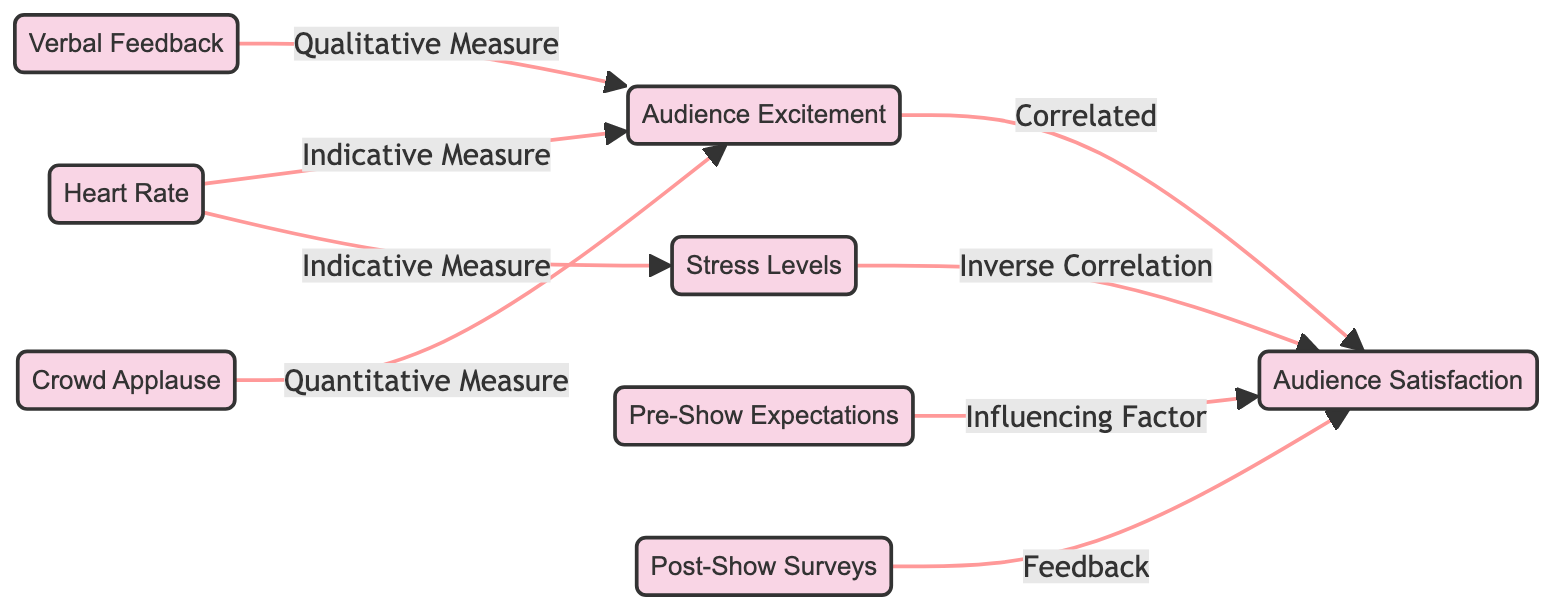What are the two main nodes related to Audience Excitement? The two main nodes related to Audience Excitement are Heart Rate and Verbal Feedback, which connect directly to Audience Excitement through indicative and qualitative measures, respectively.
Answer: Heart Rate, Verbal Feedback How many total nodes are present in the diagram? The diagram consists of eight nodes: Audience Excitement, Stress Levels, Audience Satisfaction, Heart Rate, Verbal Feedback, Crowd Applause, Pre-Show Expectations, and Post-Show Surveys.
Answer: Eight What is the relationship between Stress Levels and Audience Satisfaction? The relationship between Stress Levels and Audience Satisfaction is an inverse correlation, indicating that as stress levels increase, audience satisfaction tends to decrease.
Answer: Inverse Correlation Which node serves as a feedback mechanism for Audience Satisfaction? The Post-Show Surveys node serves as a feedback mechanism for Audience Satisfaction, indicated by its connection where it provides feedback directly influencing audience satisfaction.
Answer: Post-Show Surveys Which factor influences Audience Satisfaction before the show begins? The Pre-Show Expectations node influences Audience Satisfaction before the show begins, as shown by its direct connection that indicates it serves as an influencing factor.
Answer: Pre-Show Expectations What type of measure does Crowd Applause represent in relation to Audience Excitement? Crowd Applause represents a quantitative measure in relation to Audience Excitement, connecting through a direct edge that indicates its role in measuring excitement levels.
Answer: Quantitative Measure What is the connection type between Heart Rate and Stress Levels? The connection type between Heart Rate and Stress Levels is indicative measure, suggesting that heart rate serves as a quantifiable indicator of stress levels during the aerobatic performance.
Answer: Indicative Measure How does Audience Excitement affect Audience Satisfaction? Audience Excitement correlates with Audience Satisfaction, meaning that higher levels of excitement are associated with increased satisfaction among the audience.
Answer: Correlated 